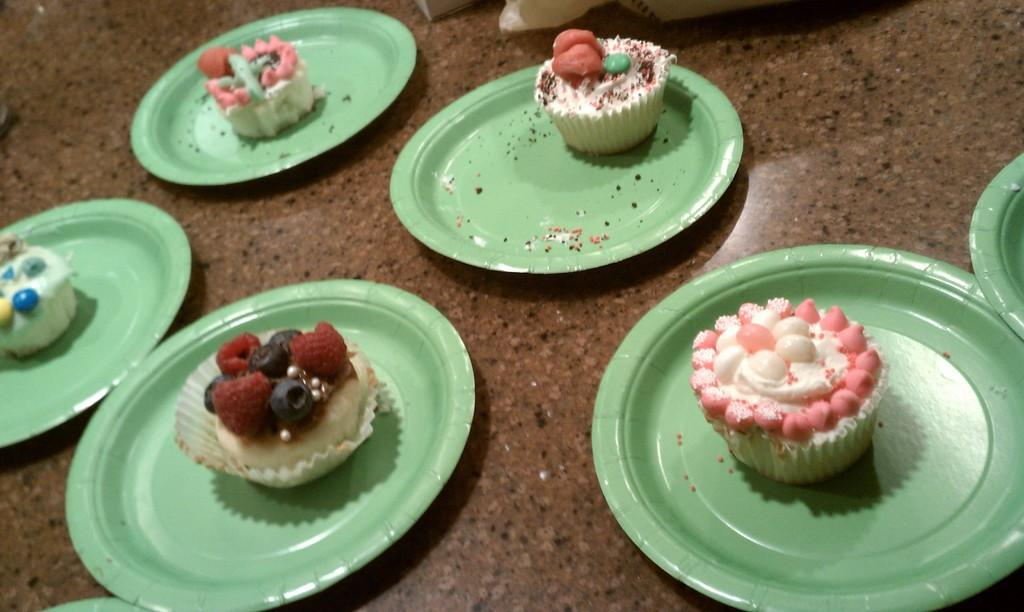What objects are present in the image that are used for serving or eating food? There are plates in the image that are used for serving or eating food. What is on the plates in the image? The plates contain food. Where are the plates located in the image? The plates are placed on a surface. What type of writing can be seen on the plates in the image? There is no writing present on the plates in the image. Can you describe the duck that is sitting on the plates in the image? There are no ducks present on the plates or in the image. 